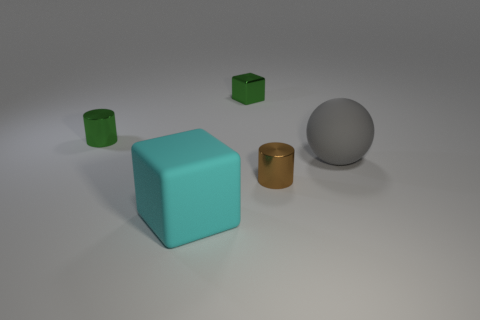Add 3 small brown things. How many objects exist? 8 Subtract all balls. How many objects are left? 4 Subtract all small matte cylinders. Subtract all green metallic cubes. How many objects are left? 4 Add 4 blocks. How many blocks are left? 6 Add 1 small green blocks. How many small green blocks exist? 2 Subtract 0 gray cylinders. How many objects are left? 5 